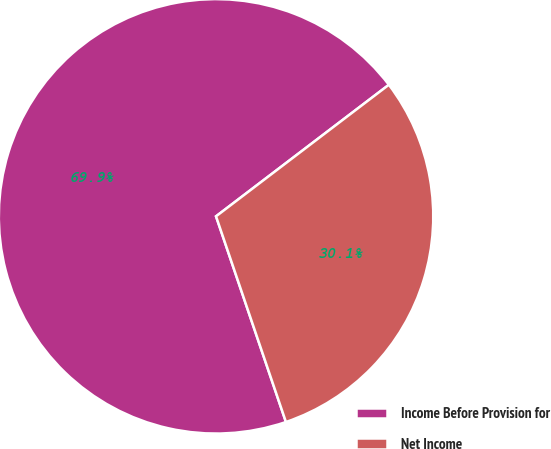<chart> <loc_0><loc_0><loc_500><loc_500><pie_chart><fcel>Income Before Provision for<fcel>Net Income<nl><fcel>69.86%<fcel>30.14%<nl></chart> 